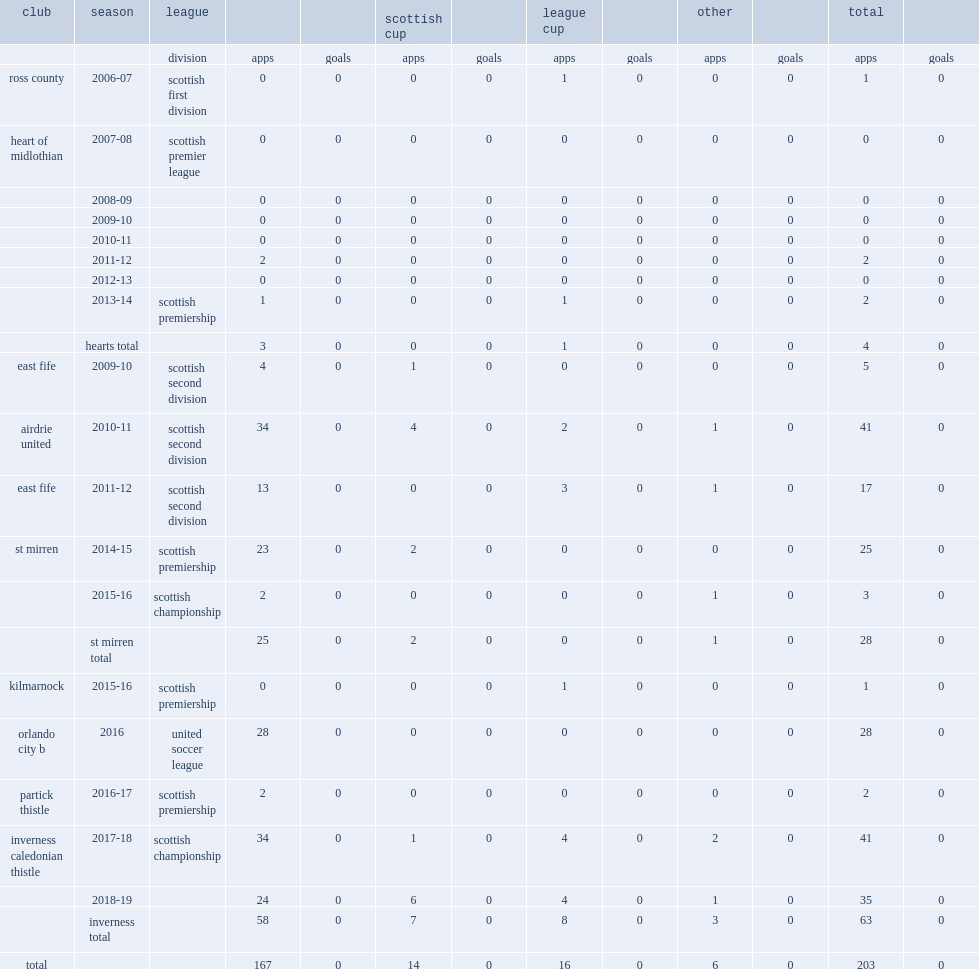Which club did ridgers play for in 2016-17? Partick thistle. 